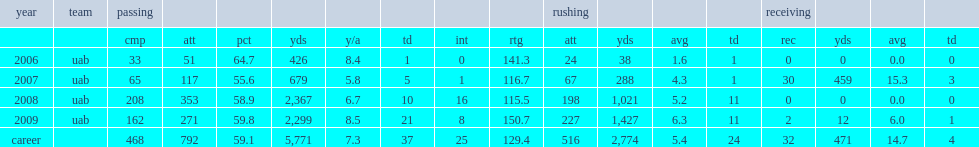How many rushing yards did webb of uab get in 2008? 1021.0. 